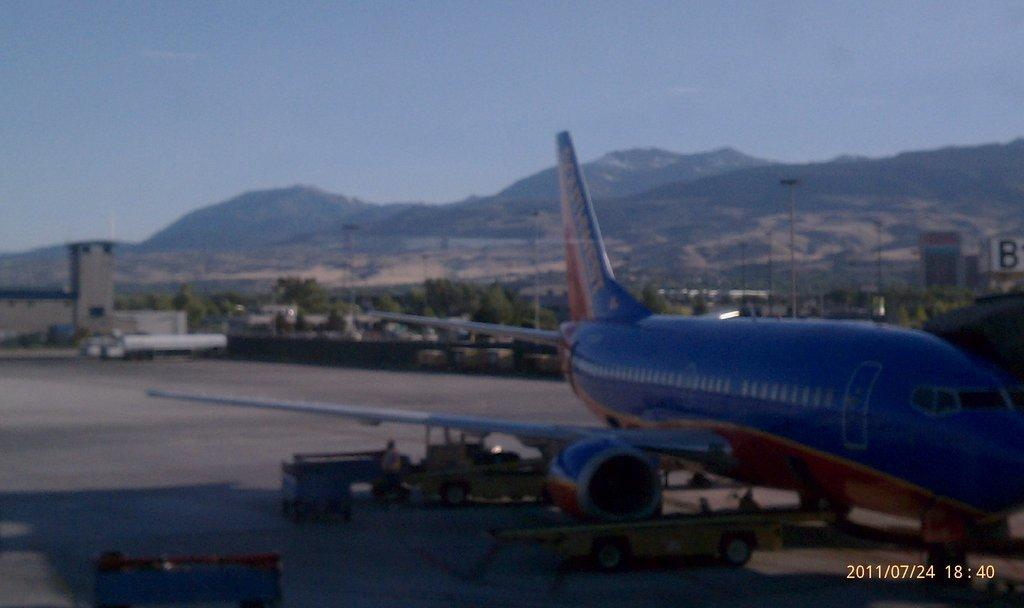What is the main subject of the image? The main subject of the image is an aeroplane. What can be seen on the ground in the image? There are vehicles and people on the road in the image. What is visible in the background of the image? Trees, poles, at least one vehicle, buildings, mountains, and the sky are visible in the background of the image. What type of shoe is being used as a symbol of authority in the image? There is no shoe present in the image, nor is there any symbol of authority depicted. 